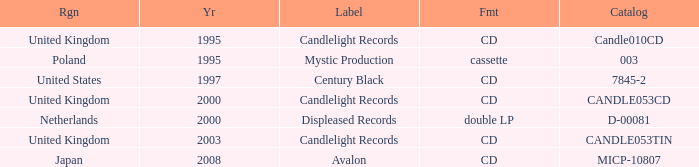What was the Candlelight Records Catalog of Candle053tin format? CD. 